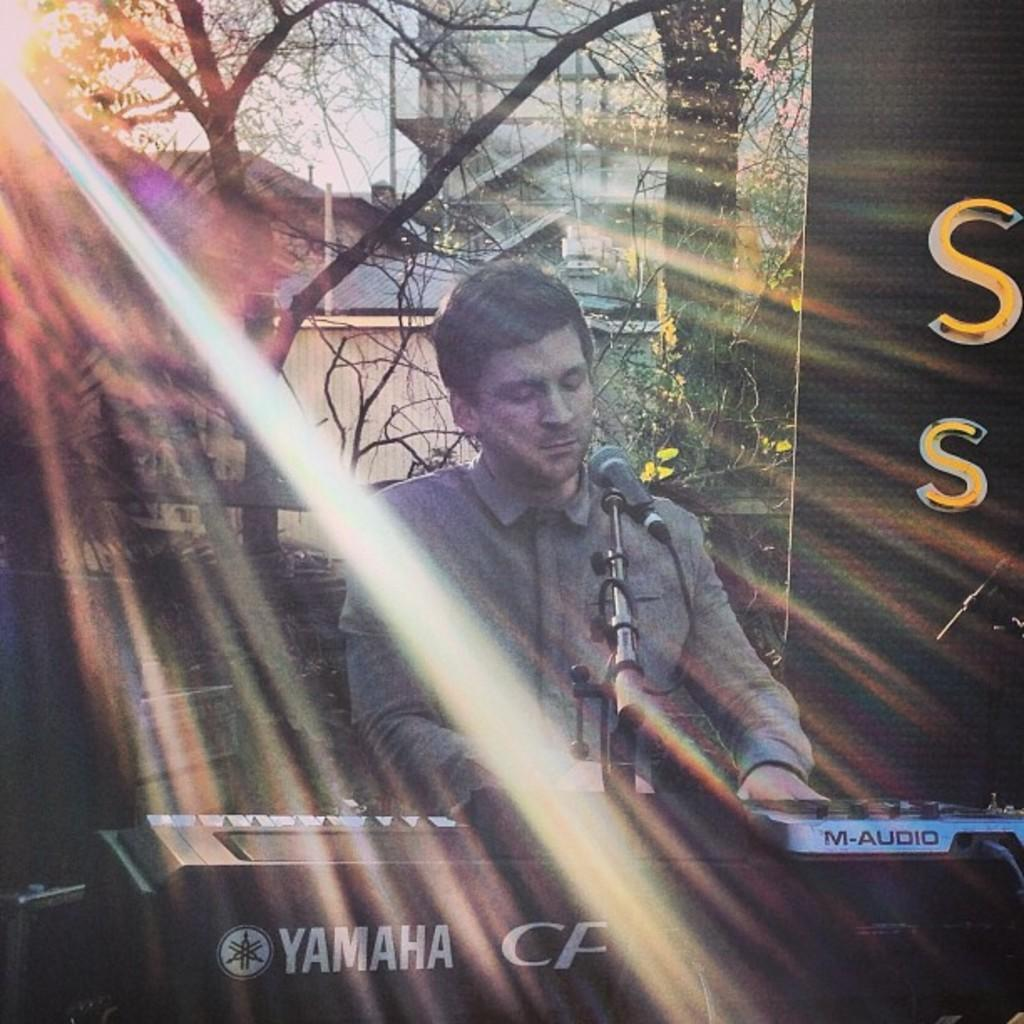What musical instrument is located at the bottom of the image? There is a piano at the bottom of the image. What is placed on the piano? There is a microphone on the piano. Who is standing near the piano? A man is standing behind the piano. What can be seen in the distance behind the piano? Trees, buildings, and the sky are visible in the background. How many chickens are sitting on the piano in the image? There are no chickens present in the image; the piano has a microphone on it. What type of frog can be seen playing the piano in the image? There is no frog playing the piano in the image; it is a man standing behind the piano. 